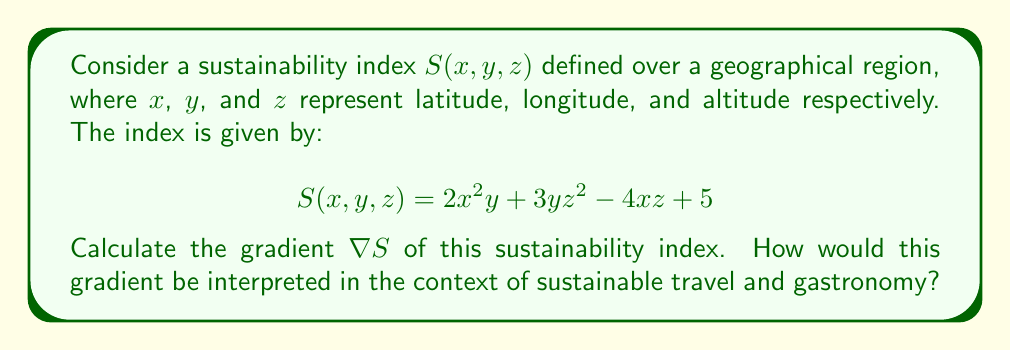Show me your answer to this math problem. To calculate the gradient of the sustainability index $S(x,y,z)$, we need to find the partial derivatives with respect to each variable:

1. Partial derivative with respect to $x$:
   $$\frac{\partial S}{\partial x} = 4xy - 4z$$

2. Partial derivative with respect to $y$:
   $$\frac{\partial S}{\partial y} = 2x^2 + 3z^2$$

3. Partial derivative with respect to $z$:
   $$\frac{\partial S}{\partial z} = 6yz - 4x$$

The gradient is then defined as:

$$\nabla S = \left(\frac{\partial S}{\partial x}, \frac{\partial S}{\partial y}, \frac{\partial S}{\partial z}\right)$$

Substituting our partial derivatives:

$$\nabla S = (4xy - 4z, 2x^2 + 3z^2, 6yz - 4x)$$

Interpretation in the context of sustainable travel and gastronomy:
The gradient $\nabla S$ represents the direction of steepest increase in the sustainability index. Each component indicates how the index changes with respect to latitude, longitude, and altitude:

1. The $x$ component $(4xy - 4z)$ shows how the index changes with latitude, considering the effects of longitude and altitude.
2. The $y$ component $(2x^2 + 3z^2)$ indicates changes with longitude, influenced by latitude and altitude.
3. The $z$ component $(6yz - 4x)$ represents changes with altitude, affected by longitude and latitude.

For a traveler interested in sustainable gastronomic experiences, this gradient could help identify regions where sustainability practices are improving most rapidly. Moving in the direction of the gradient would lead to areas with potentially more sustainable food options and eco-friendly travel experiences.
Answer: $\nabla S = (4xy - 4z, 2x^2 + 3z^2, 6yz - 4x)$ 